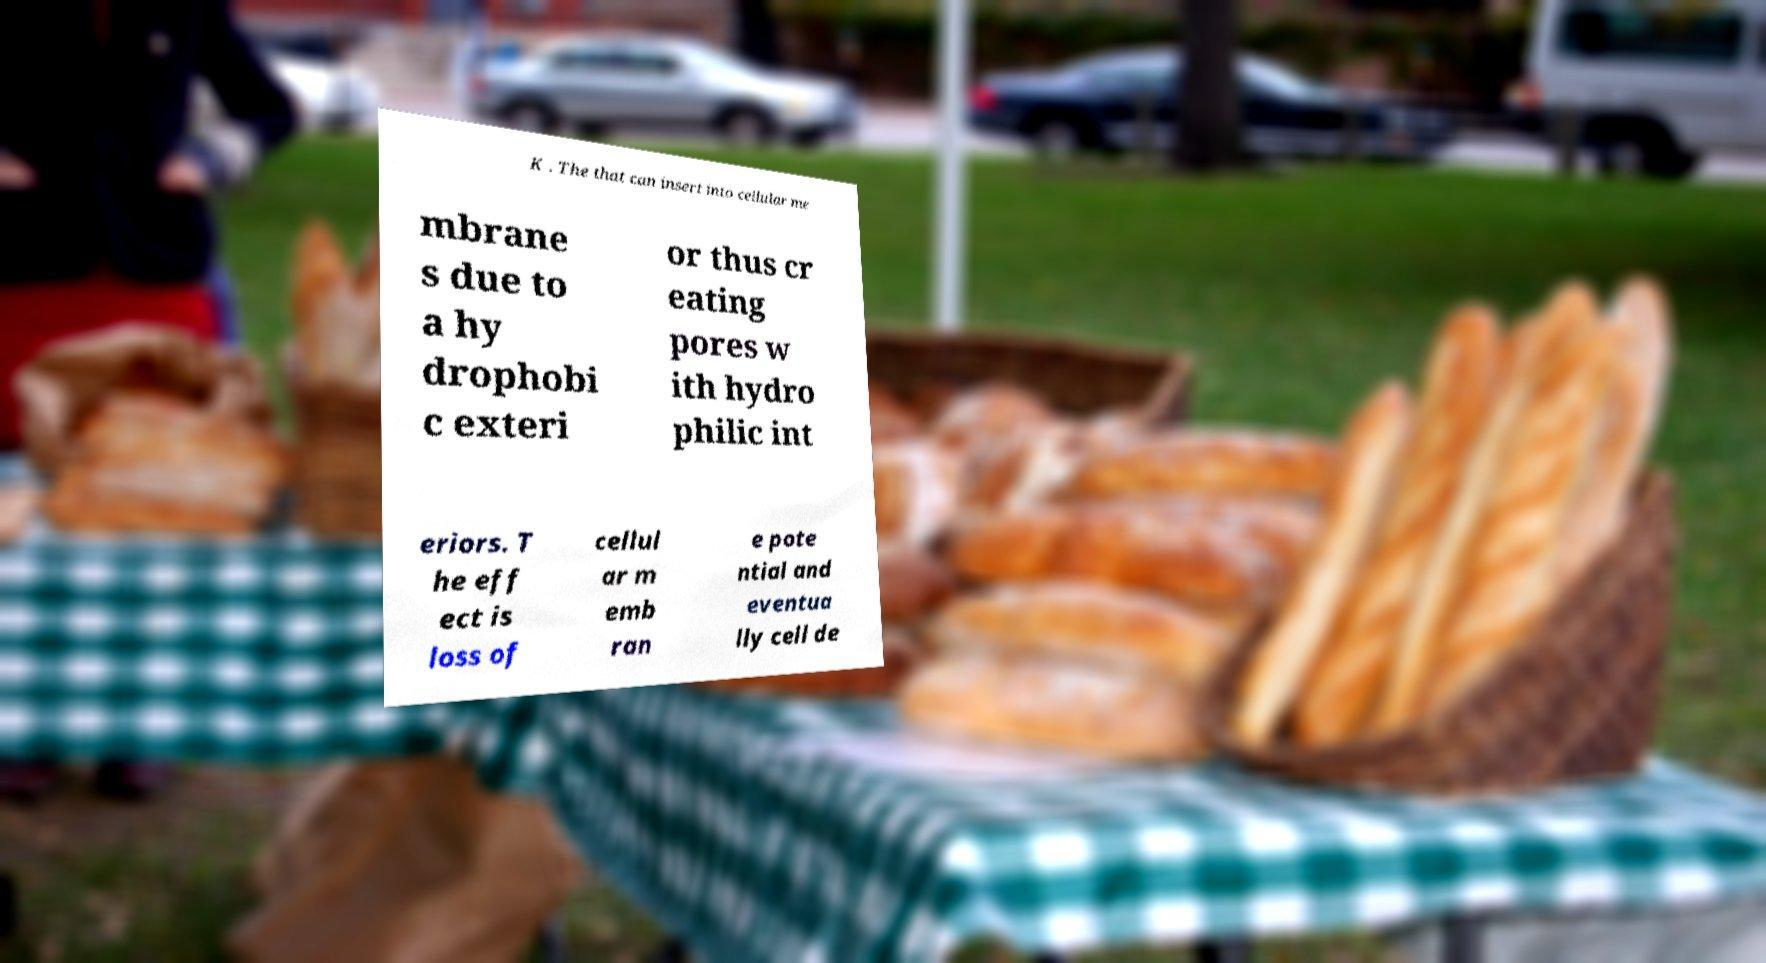There's text embedded in this image that I need extracted. Can you transcribe it verbatim? K . The that can insert into cellular me mbrane s due to a hy drophobi c exteri or thus cr eating pores w ith hydro philic int eriors. T he eff ect is loss of cellul ar m emb ran e pote ntial and eventua lly cell de 